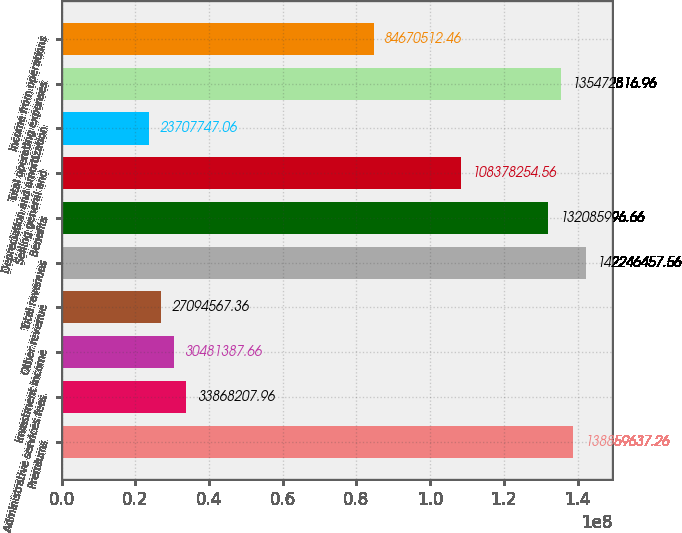Convert chart. <chart><loc_0><loc_0><loc_500><loc_500><bar_chart><fcel>Premiums<fcel>Administrative services fees<fcel>Investment income<fcel>Other revenue<fcel>Total revenues<fcel>Benefits<fcel>Selling general and<fcel>Depreciation and amortization<fcel>Total operating expenses<fcel>Income from operations<nl><fcel>1.3886e+08<fcel>3.38682e+07<fcel>3.04814e+07<fcel>2.70946e+07<fcel>1.42246e+08<fcel>1.32086e+08<fcel>1.08378e+08<fcel>2.37077e+07<fcel>1.35473e+08<fcel>8.46705e+07<nl></chart> 